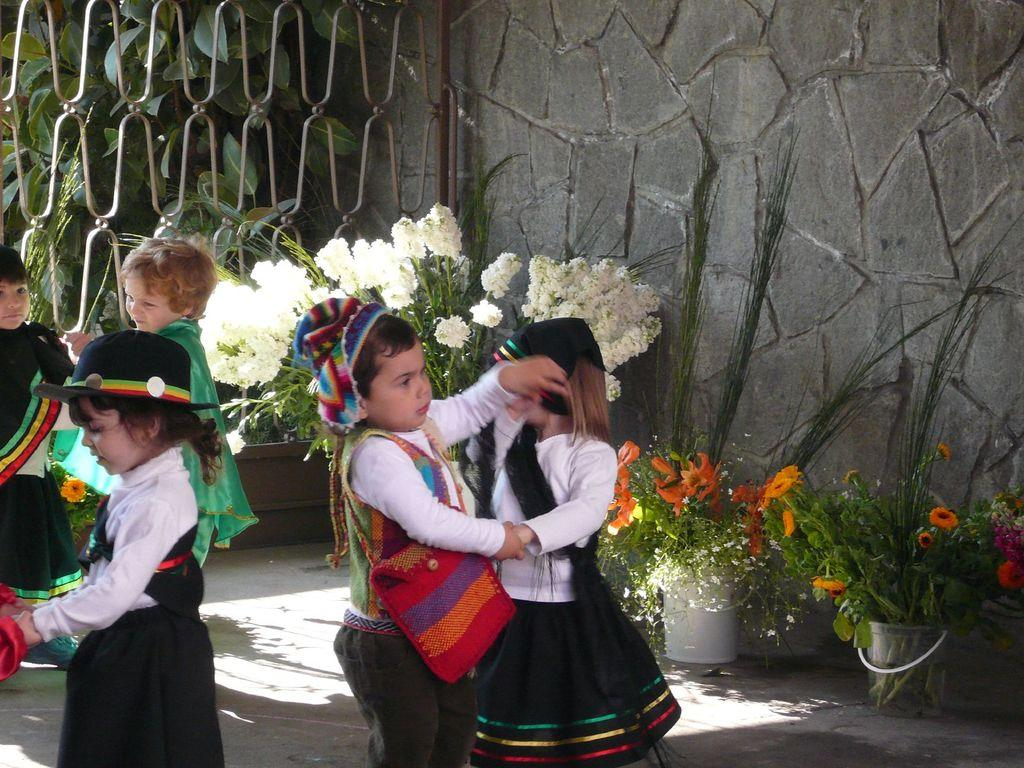How many kids are in the image? There are kids in the image, but the exact number is not specified. What are the kids doing in the image? The kids are dancing in the image. What are the kids wearing in the image? The kids are wearing different costumes in the image. What can be seen in the background of the image? In the background of the image, there is a wall, a fence, trees, plants, plant pots, and flowers. What type of balls are the kids playing with in the image? There is no mention of balls in the image; the kids are dancing and wearing different costumes. 